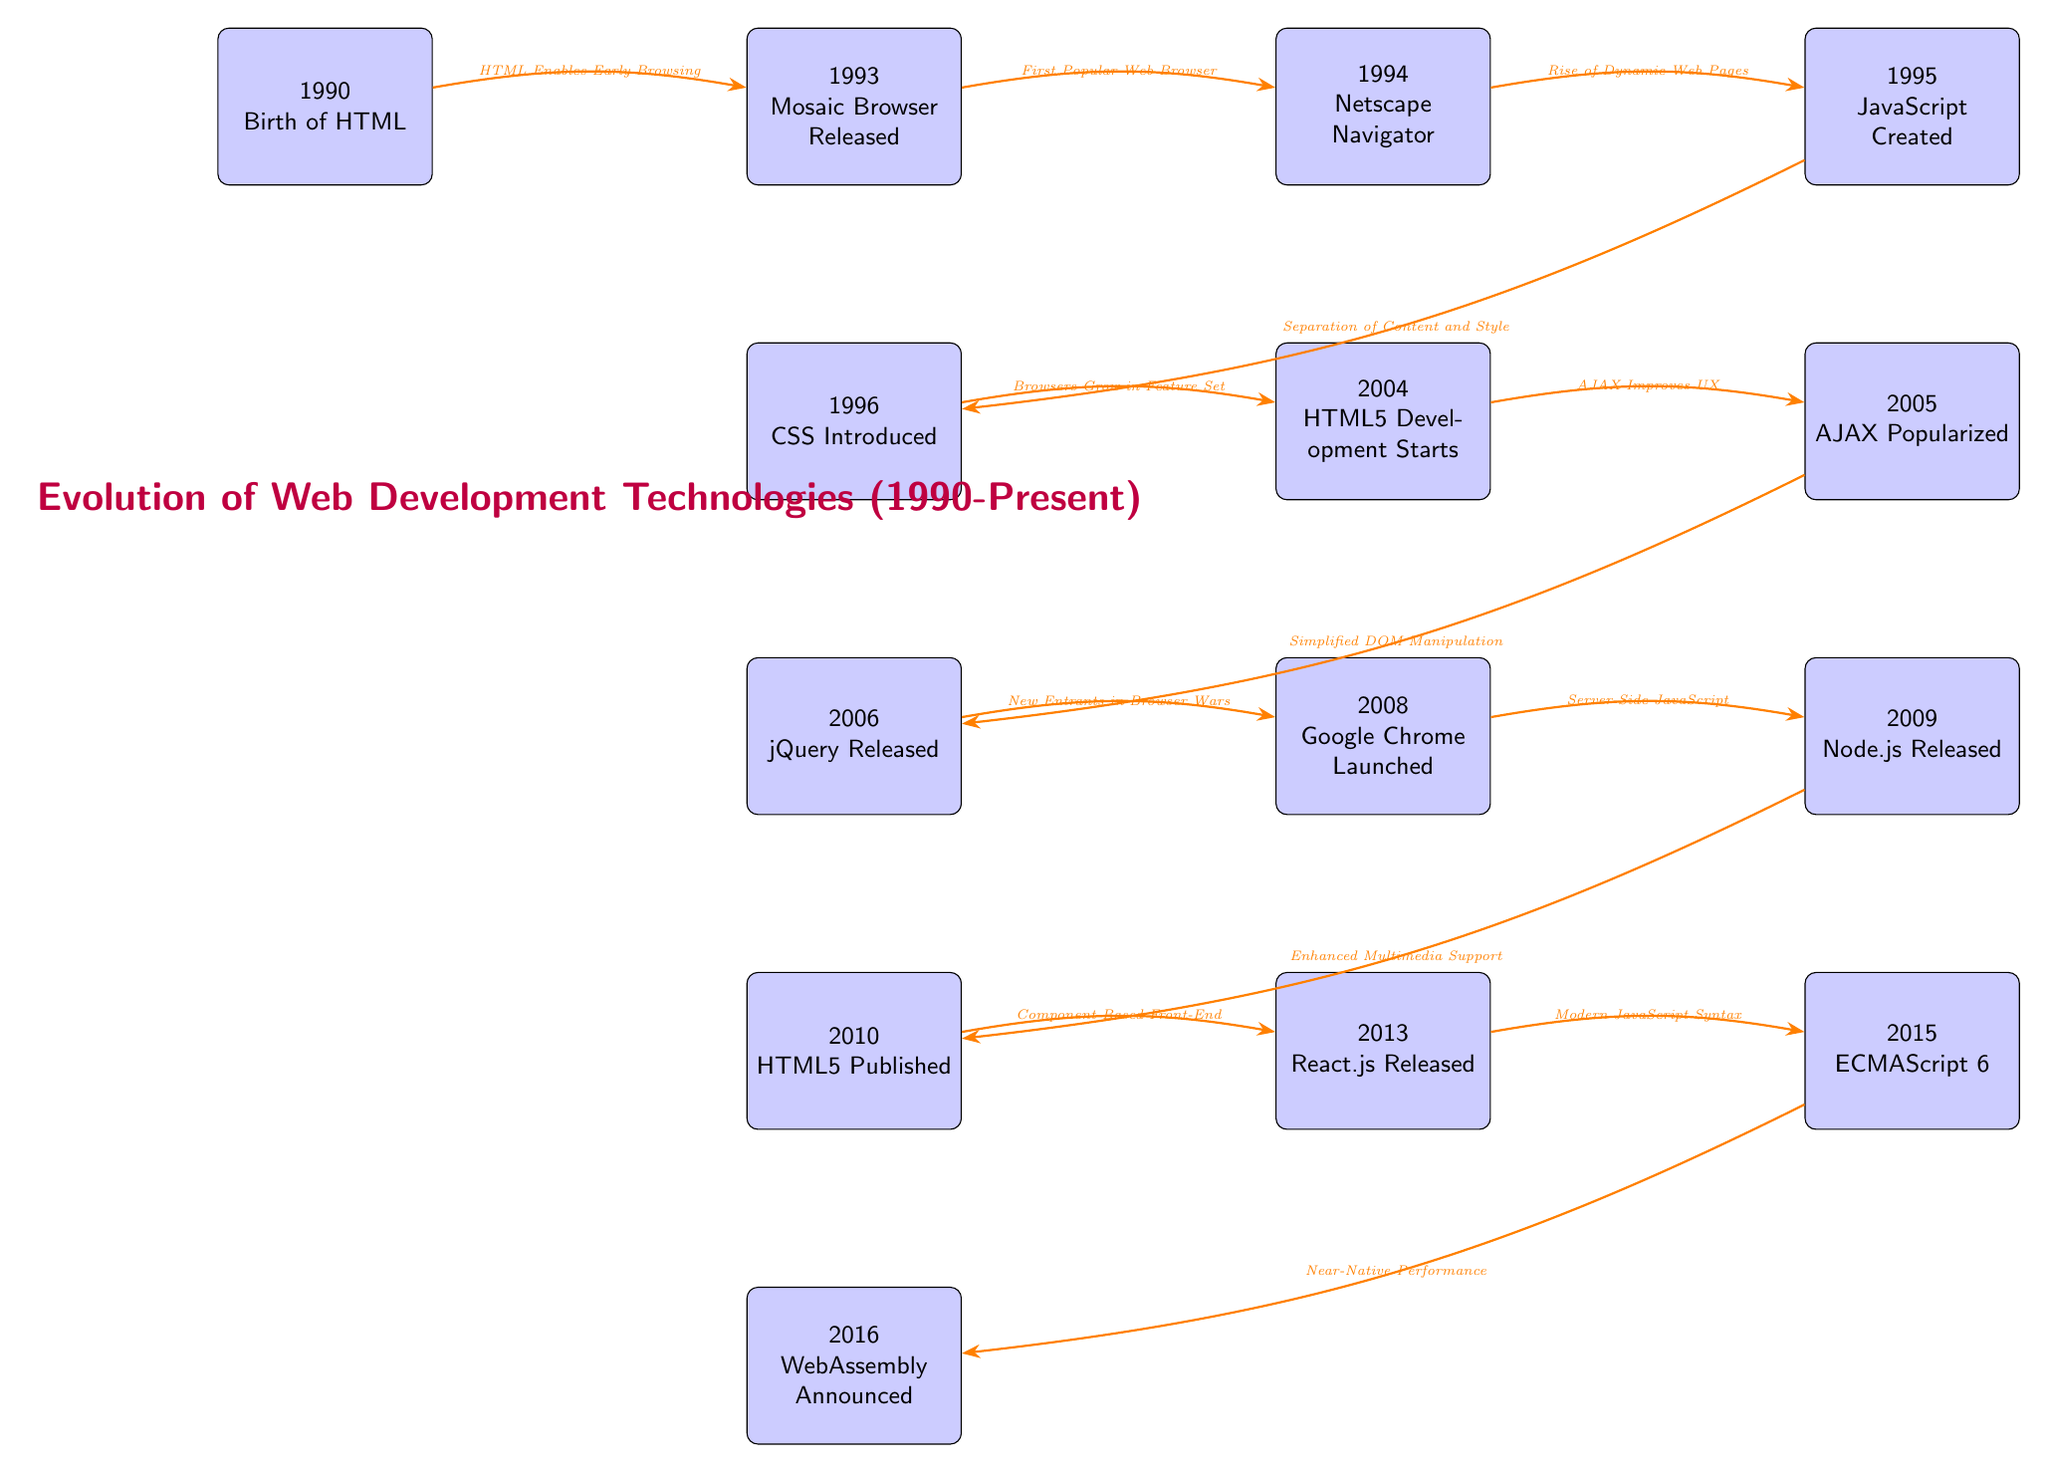What event marks the birth of web development? The diagram identifies the node labeled "1990" which states "Birth of HTML" as the starting point of web development technologies.
Answer: Birth of HTML How many key milestones are listed on the diagram? By counting the nodes from "1990" to "2016", there are a total of 13 milestones represented in the diagram.
Answer: 13 What technology was introduced in 1996? The node positioned below "1993" specifies "CSS Introduced" as the event that occurred in 1996.
Answer: CSS Introduced Which event is linked to increased user experience through AJAX? Looking at the connection from the node "2004", which indicates "HTML5 Development Starts," the arrow leads to "AJAX Popularized" as the event that improved user experience.
Answer: AJAX Popularized What was the relationship between JavaScript and the development of dynamic web pages? The connection from "1994" (Netscape Navigator) to "1995" (JavaScript Created) indicates that JavaScript was needed to support the rise of Dynamic Web Pages.
Answer: Rise of Dynamic Web Pages What major milestone follows the release of jQuery in 2006? The node "2010" which shows "HTML5 Published" directly follows the node "2006" for jQuery, indicating that it is the event that comes next.
Answer: HTML5 Published Which technology aimed to enable server-side JavaScript? The edge connecting "2008" (Google Chrome Launched) to "2009" (Node.js Released) illustrates that the release of Node.js aimed to enable server-side JavaScript.
Answer: Node.js Released What does the arrow between "2010" and "2013" signify? The arrow between these two nodes indicates that the publishing of HTML5 led to the introduction of component-based front-end frameworks, specifically represented by "React.js Released."
Answer: Component-Based Front-End What does the 2016 milestone focus on in terms of web performance? The event "2016" is associated with "WebAssembly Announced," which is relevant for near-native performance improvements in web applications.
Answer: Near-Native Performance 